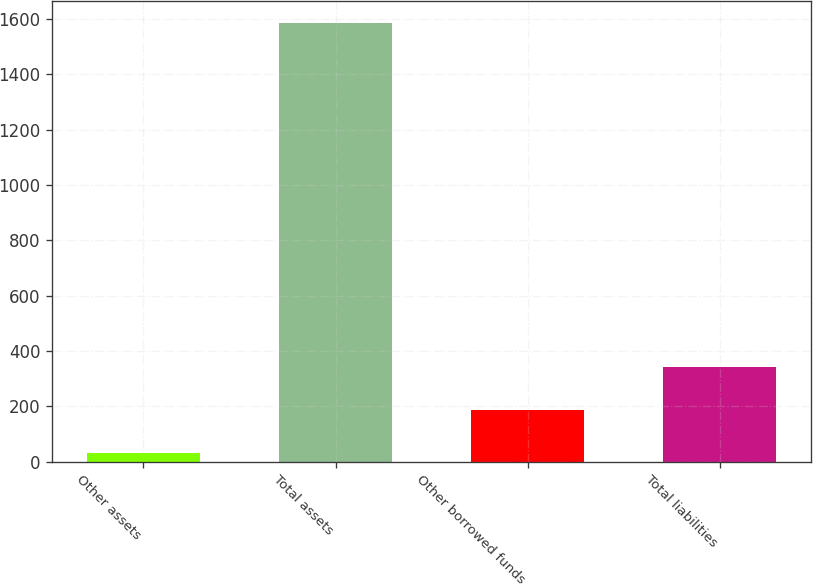<chart> <loc_0><loc_0><loc_500><loc_500><bar_chart><fcel>Other assets<fcel>Total assets<fcel>Other borrowed funds<fcel>Total liabilities<nl><fcel>31<fcel>1587<fcel>186.6<fcel>342.2<nl></chart> 